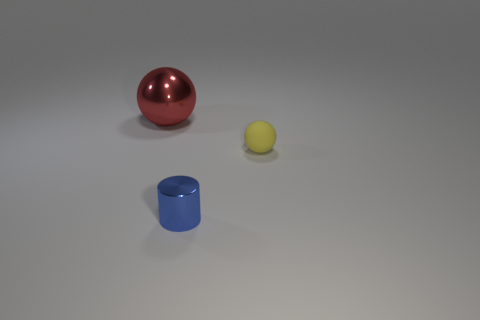Add 3 tiny cylinders. How many objects exist? 6 Subtract all cylinders. How many objects are left? 2 Add 3 blue shiny objects. How many blue shiny objects are left? 4 Add 1 tiny yellow shiny blocks. How many tiny yellow shiny blocks exist? 1 Subtract 0 brown blocks. How many objects are left? 3 Subtract all small yellow matte objects. Subtract all matte objects. How many objects are left? 1 